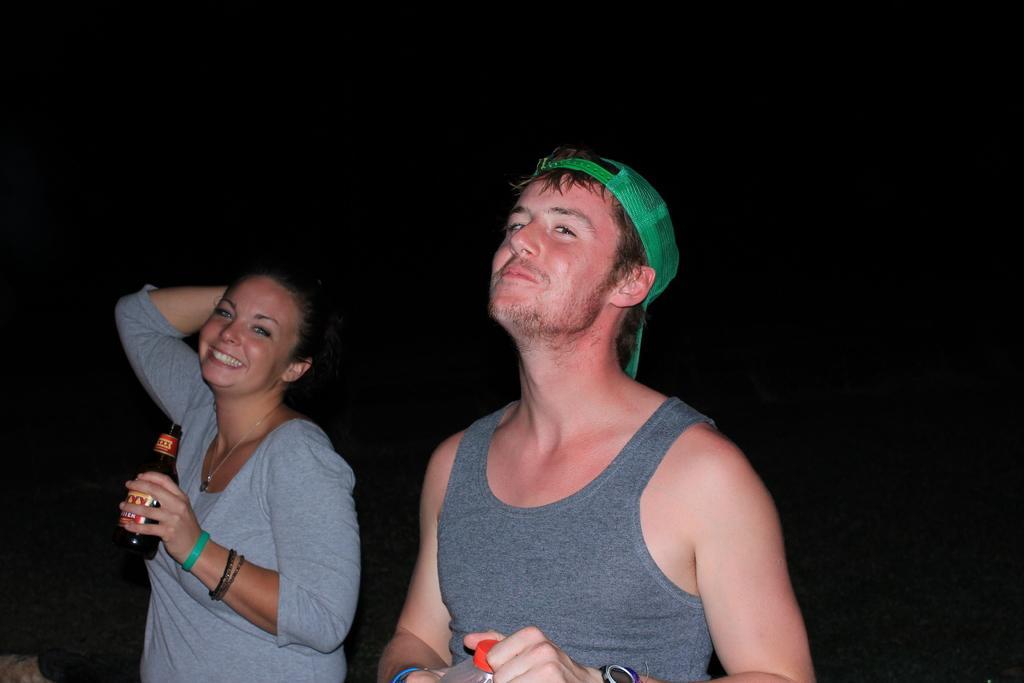How would you summarize this image in a sentence or two? In this picture we can see there are two persons holding the bottles. Behind the two persons, there is the dark background. 